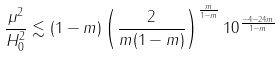<formula> <loc_0><loc_0><loc_500><loc_500>\frac { \mu ^ { 2 } } { H _ { 0 } ^ { 2 } } \lesssim ( 1 - m ) \left ( \frac { 2 } { m ( 1 - m ) } \right ) ^ { \frac { m } { 1 - m } } 1 0 ^ { \frac { - 4 - 2 4 m } { 1 - m } }</formula> 